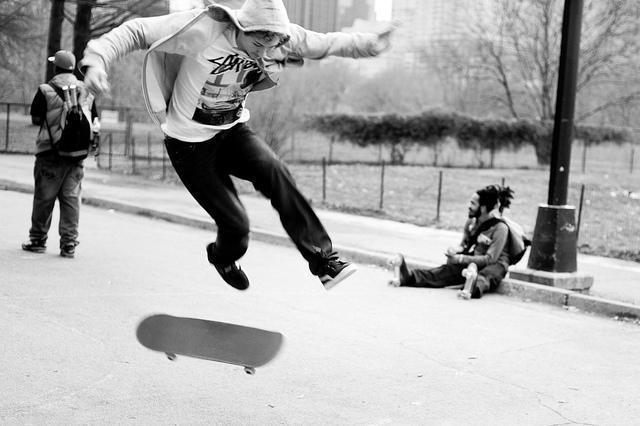How many people are there?
Give a very brief answer. 3. 